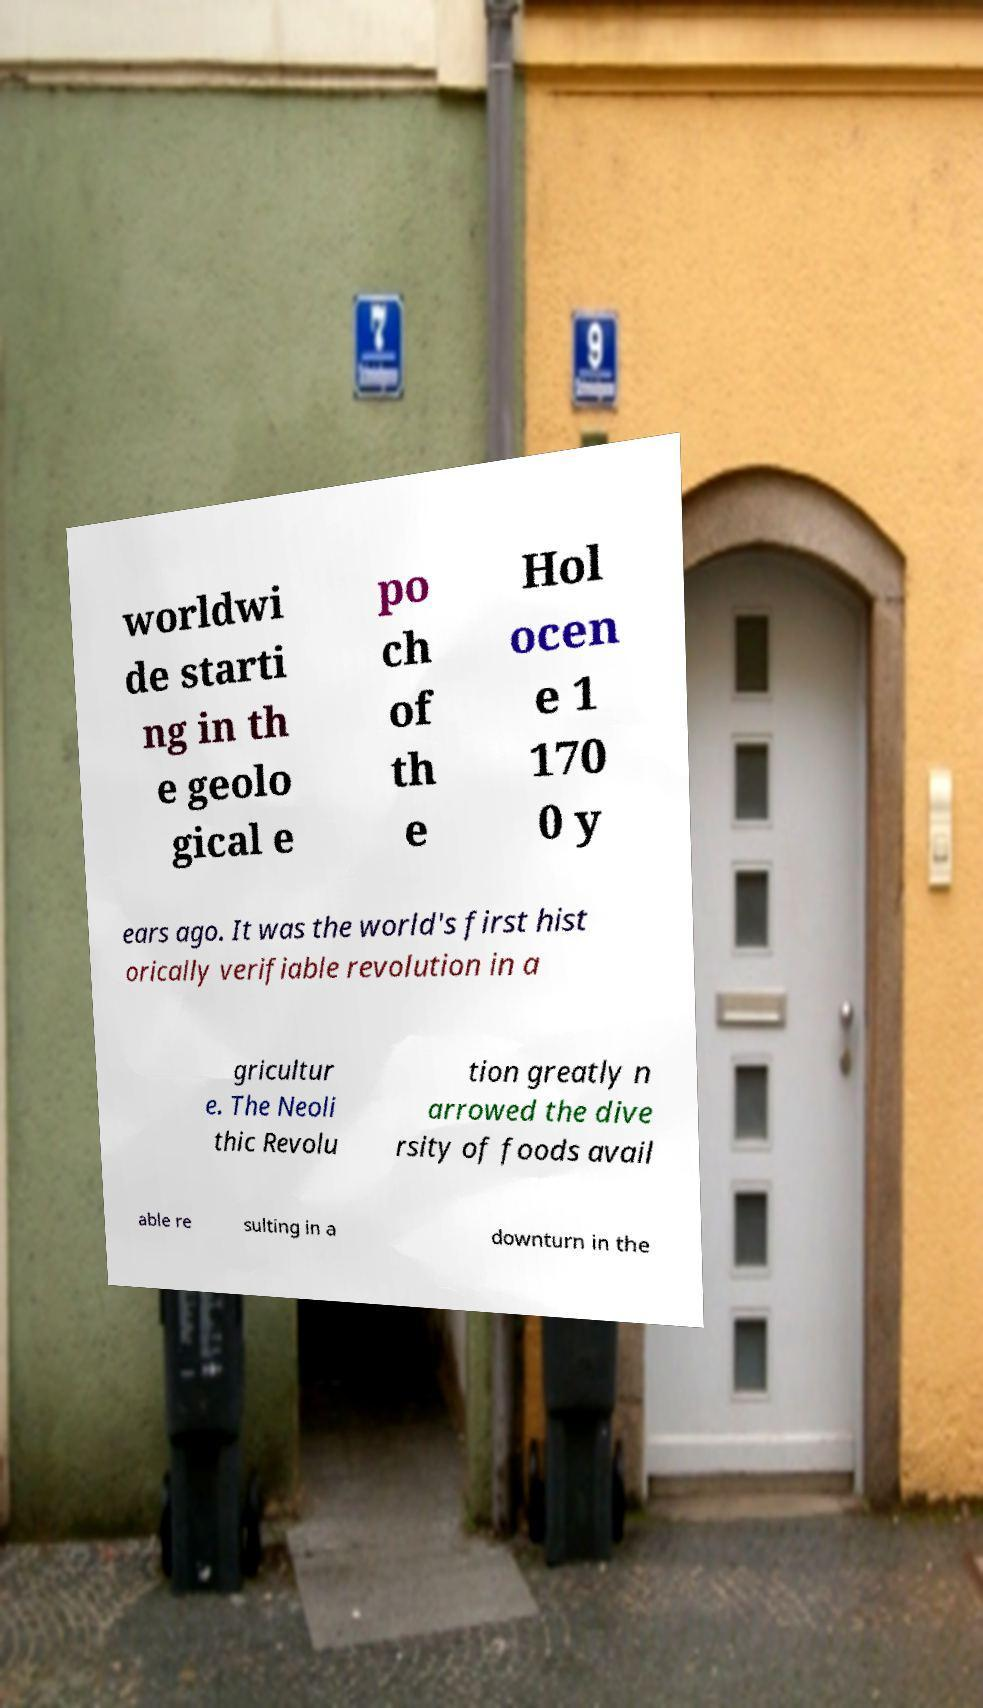Please identify and transcribe the text found in this image. worldwi de starti ng in th e geolo gical e po ch of th e Hol ocen e 1 170 0 y ears ago. It was the world's first hist orically verifiable revolution in a gricultur e. The Neoli thic Revolu tion greatly n arrowed the dive rsity of foods avail able re sulting in a downturn in the 